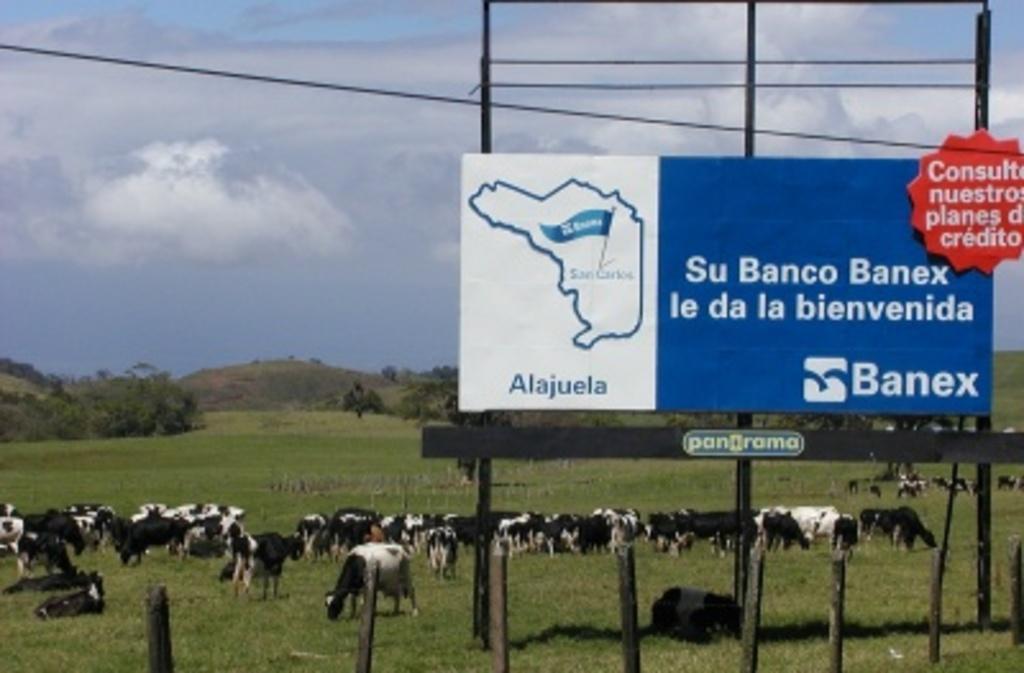In one or two sentences, can you explain what this image depicts? We can see hoarding and board on poles. We can see poles,wire,object on grass and animals. In the background we can see trees,hill and sky with clouds. 